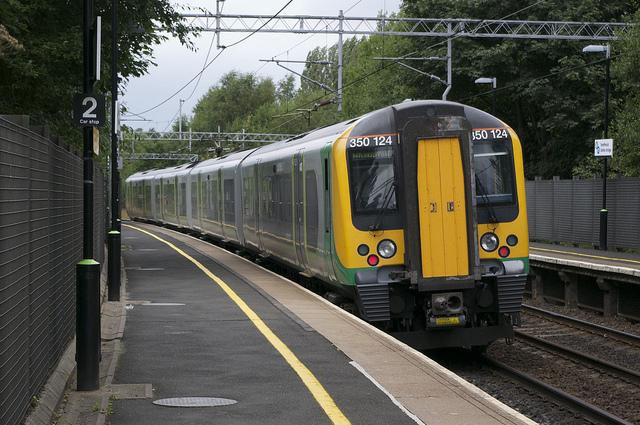Are the doors of the train closed?
Short answer required. Yes. Are the train's headlights on?
Short answer required. No. What is the purpose of the yellow line on the ground?
Be succinct. Safety. What is along the platform?
Quick response, please. Yellow line. 